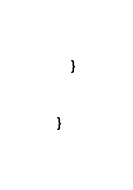Convert code to text. <code><loc_0><loc_0><loc_500><loc_500><_Java_>    }


}
</code> 